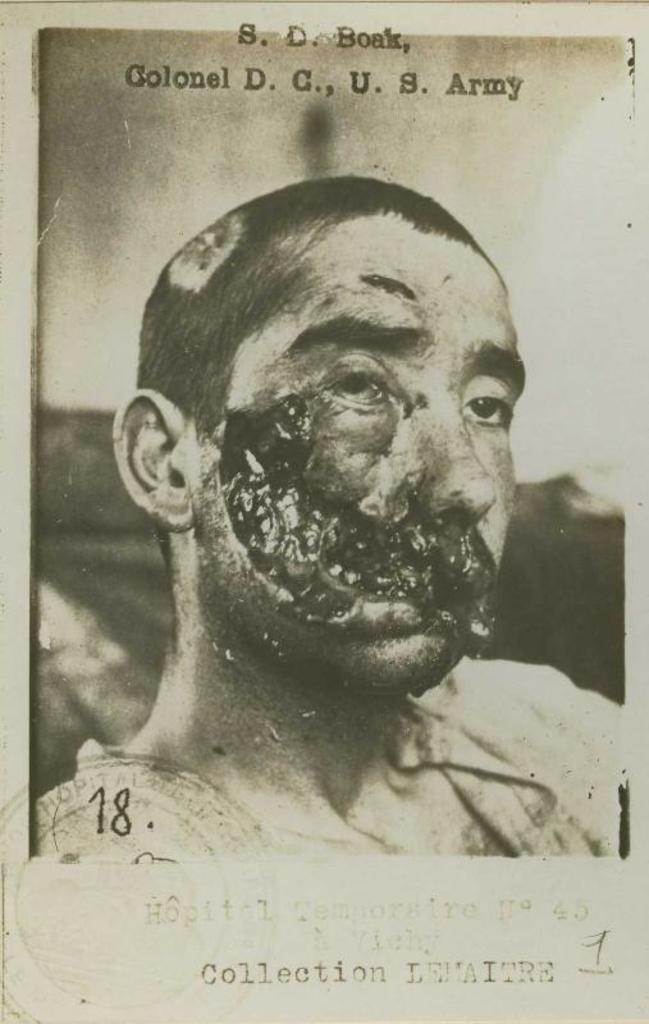What is the main subject of the image? There is a photo in the image. What can be seen in the photo? The photo contains a depiction of a person. Is there any additional information associated with the photo? Yes, there is text associated with the photo. What type of net is being used to catch the cloth in the image? There is no net or cloth present in the image; it only contains a photo with a depiction of a person and associated text. 